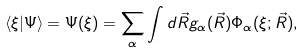Convert formula to latex. <formula><loc_0><loc_0><loc_500><loc_500>\langle \xi | \Psi \rangle = \Psi ( \xi ) = \sum _ { \alpha } \int d \vec { R } g _ { \alpha } ( \vec { R } ) \Phi _ { \alpha } ( \xi ; \vec { R } ) ,</formula> 